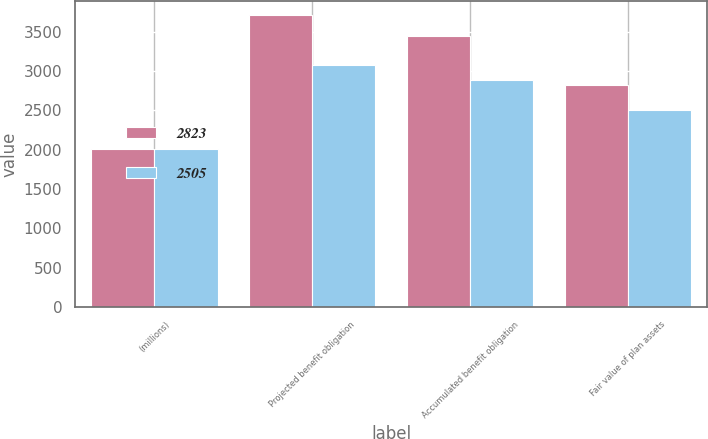Convert chart. <chart><loc_0><loc_0><loc_500><loc_500><stacked_bar_chart><ecel><fcel>(millions)<fcel>Projected benefit obligation<fcel>Accumulated benefit obligation<fcel>Fair value of plan assets<nl><fcel>2823<fcel>2012<fcel>3707<fcel>3442<fcel>2823<nl><fcel>2505<fcel>2011<fcel>3077<fcel>2882<fcel>2505<nl></chart> 